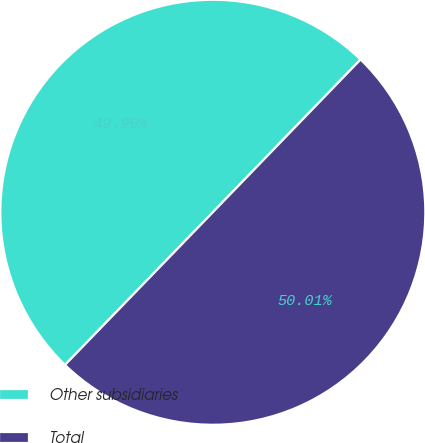<chart> <loc_0><loc_0><loc_500><loc_500><pie_chart><fcel>Other subsidiaries<fcel>Total<nl><fcel>49.99%<fcel>50.01%<nl></chart> 